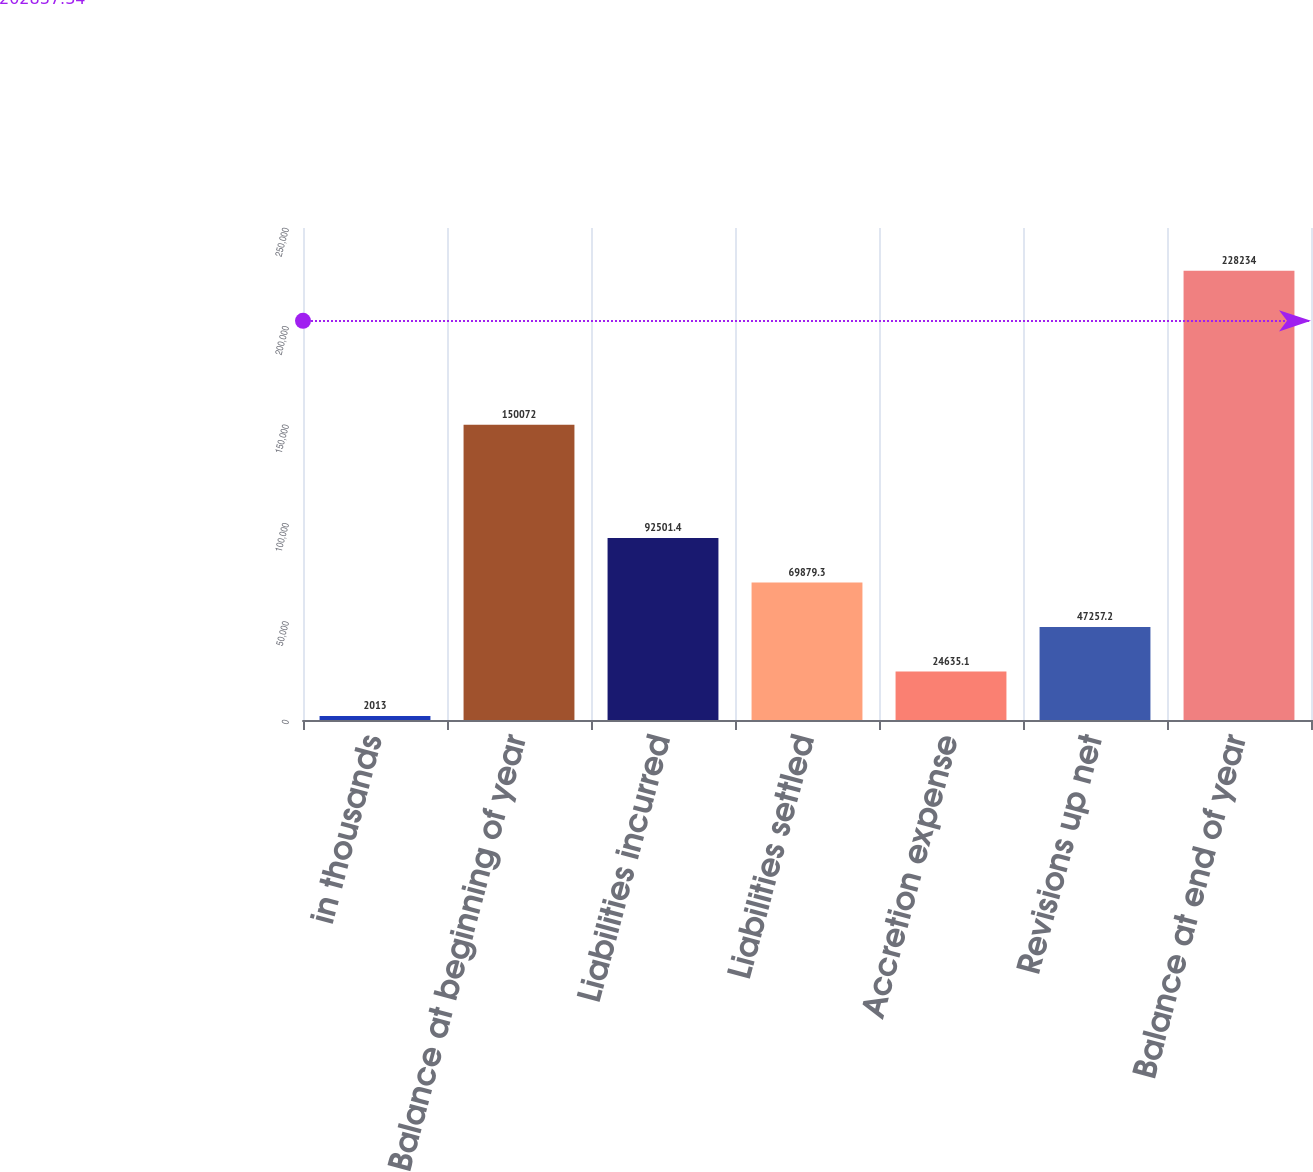Convert chart to OTSL. <chart><loc_0><loc_0><loc_500><loc_500><bar_chart><fcel>in thousands<fcel>Balance at beginning of year<fcel>Liabilities incurred<fcel>Liabilities settled<fcel>Accretion expense<fcel>Revisions up net<fcel>Balance at end of year<nl><fcel>2013<fcel>150072<fcel>92501.4<fcel>69879.3<fcel>24635.1<fcel>47257.2<fcel>228234<nl></chart> 